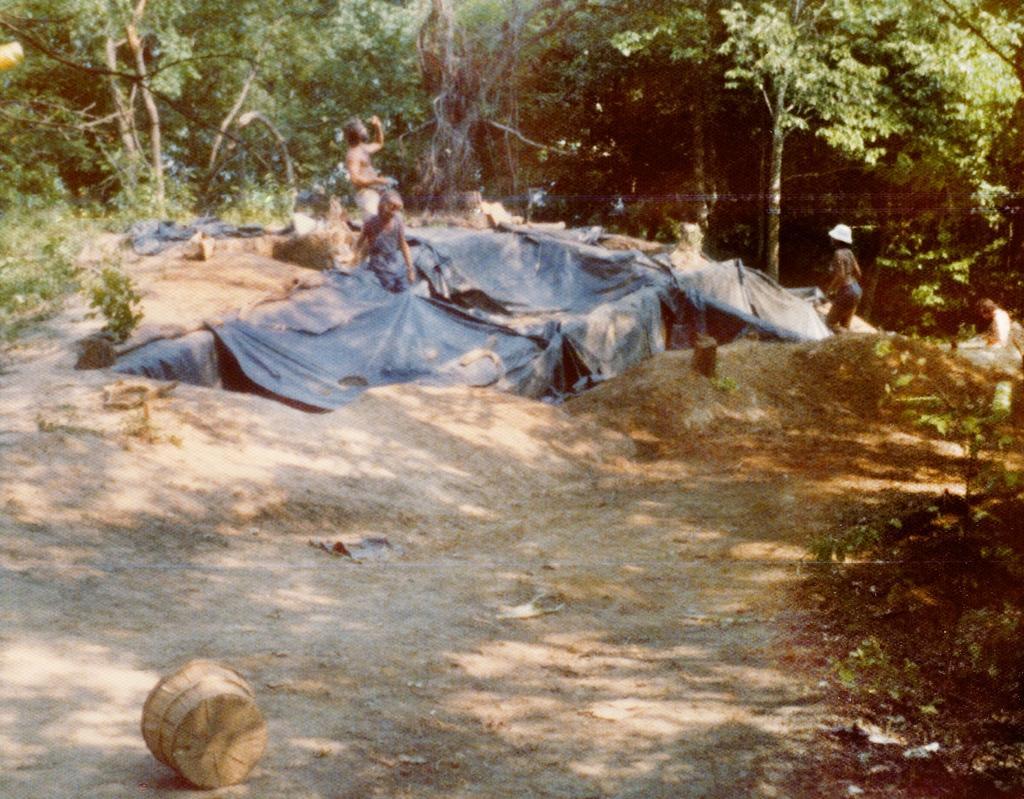How would you summarize this image in a sentence or two? In the image we can see there are people wearing clothes and one person is wearing a cap. Here we can see wooden basket, grass and trees. 